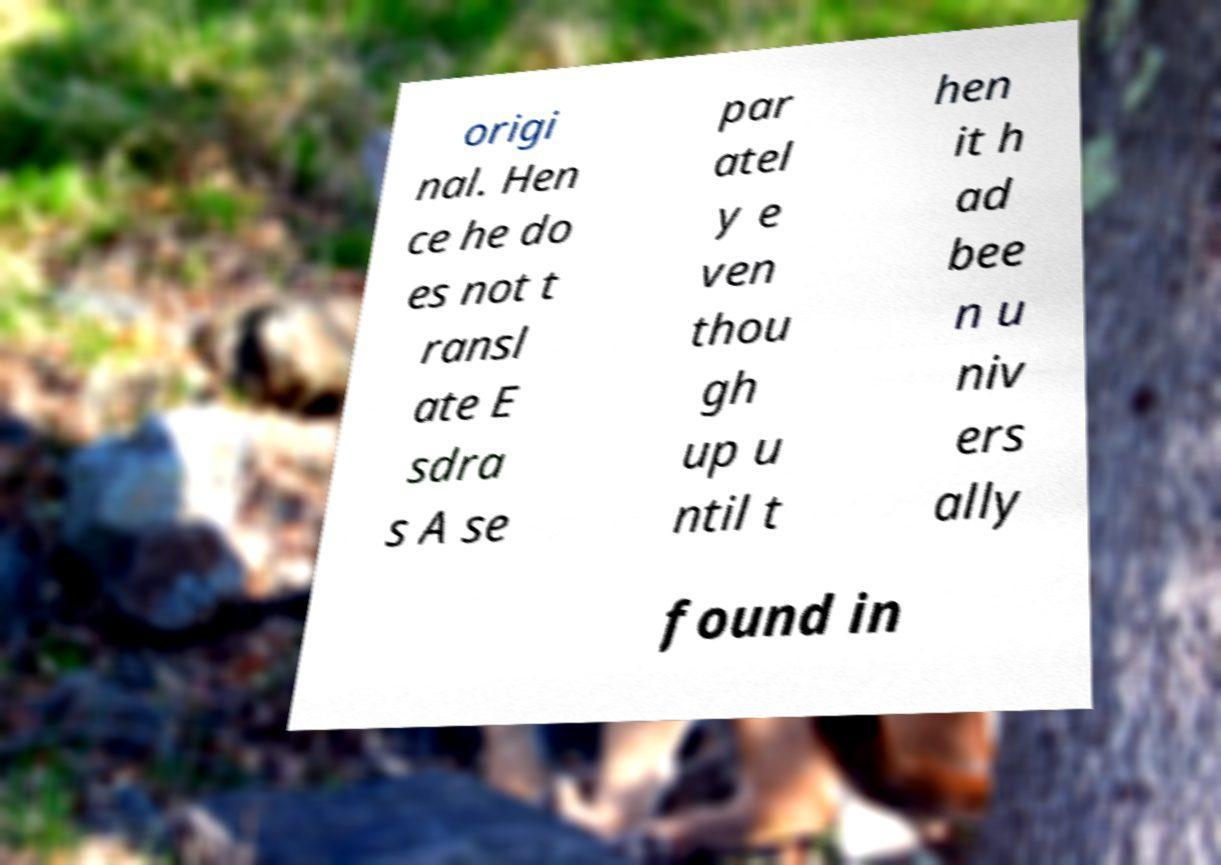What messages or text are displayed in this image? I need them in a readable, typed format. origi nal. Hen ce he do es not t ransl ate E sdra s A se par atel y e ven thou gh up u ntil t hen it h ad bee n u niv ers ally found in 